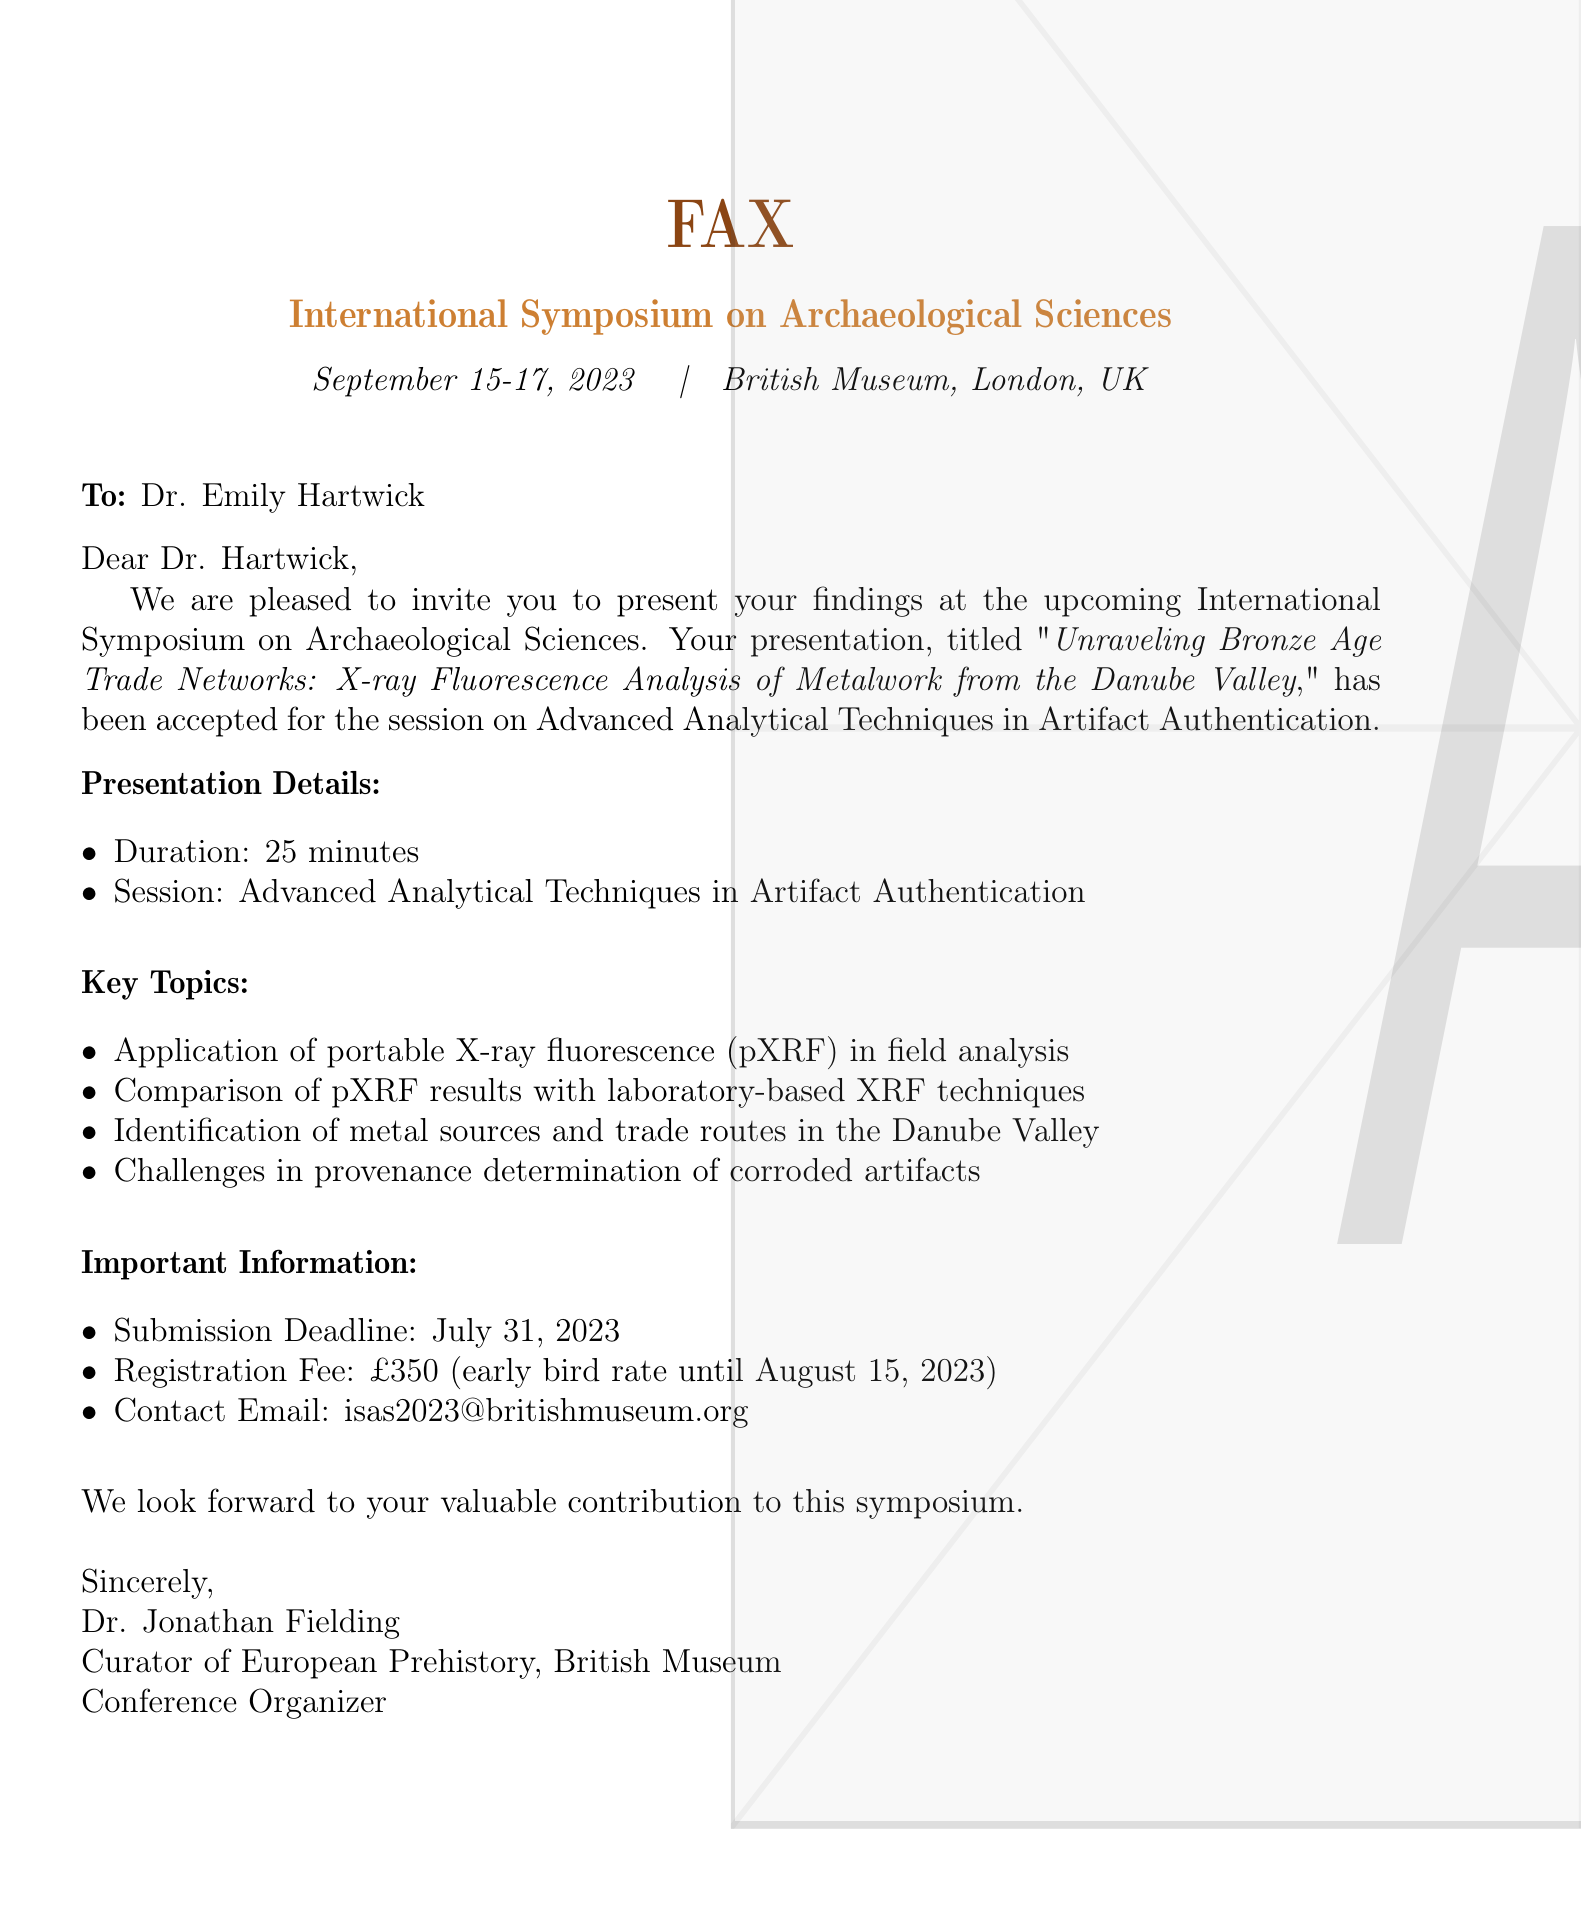What is the title of Dr. Hartwick's presentation? The title of the presentation is explicitly mentioned in the document as "\textit{Unraveling Bronze Age Trade Networks: X-ray Fluorescence Analysis of Metalwork from the Danube Valley}".
Answer: Unraveling Bronze Age Trade Networks: X-ray Fluorescence Analysis of Metalwork from the Danube Valley What are the dates of the symposium? The dates of the symposium are stated in the document as "September 15-17, 2023".
Answer: September 15-17, 2023 Who is the conference organizer? The document names Dr. Jonathan Fielding as the conference organizer.
Answer: Dr. Jonathan Fielding What is the early bird registration fee? The early bird registration fee is mentioned as £350, with a note about the deadline for this rate.
Answer: £350 What are two key topics discussed in the presentation? The document lists key topics including "Application of portable X-ray fluorescence (pXRF) in field analysis" and "Challenges in provenance determination of corroded artifacts".
Answer: Application of portable X-ray fluorescence (pXRF) in field analysis; Challenges in provenance determination of corroded artifacts What is the submission deadline for the presentation? The deadline for submission is clearly stated in the document as "July 31, 2023".
Answer: July 31, 2023 What session will Dr. Hartwick's presentation be part of? The document specifies that the session is "Advanced Analytical Techniques in Artifact Authentication".
Answer: Advanced Analytical Techniques in Artifact Authentication How long is the presentation scheduled to last? The presentation duration is stated in the document as "25 minutes".
Answer: 25 minutes 